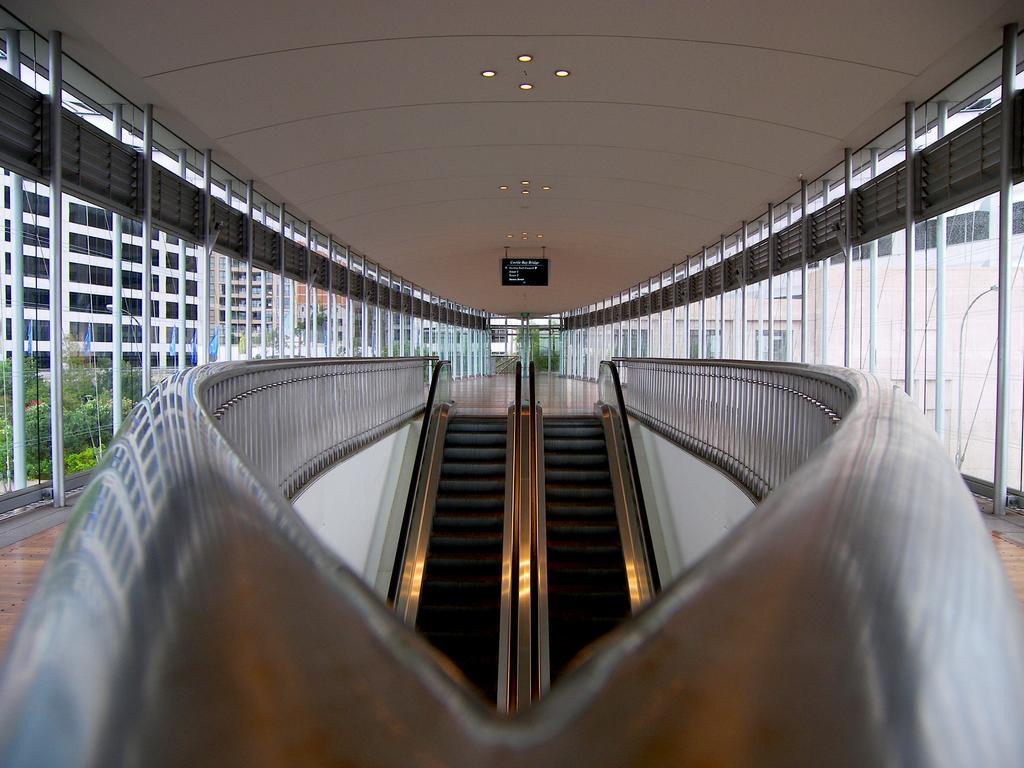Can you describe this image briefly? At the top we can see the ceiling, board and the lights. On the left side of the picture we can see the buildings, flags and the trees. This picture is mainly highlighted with escalators. 